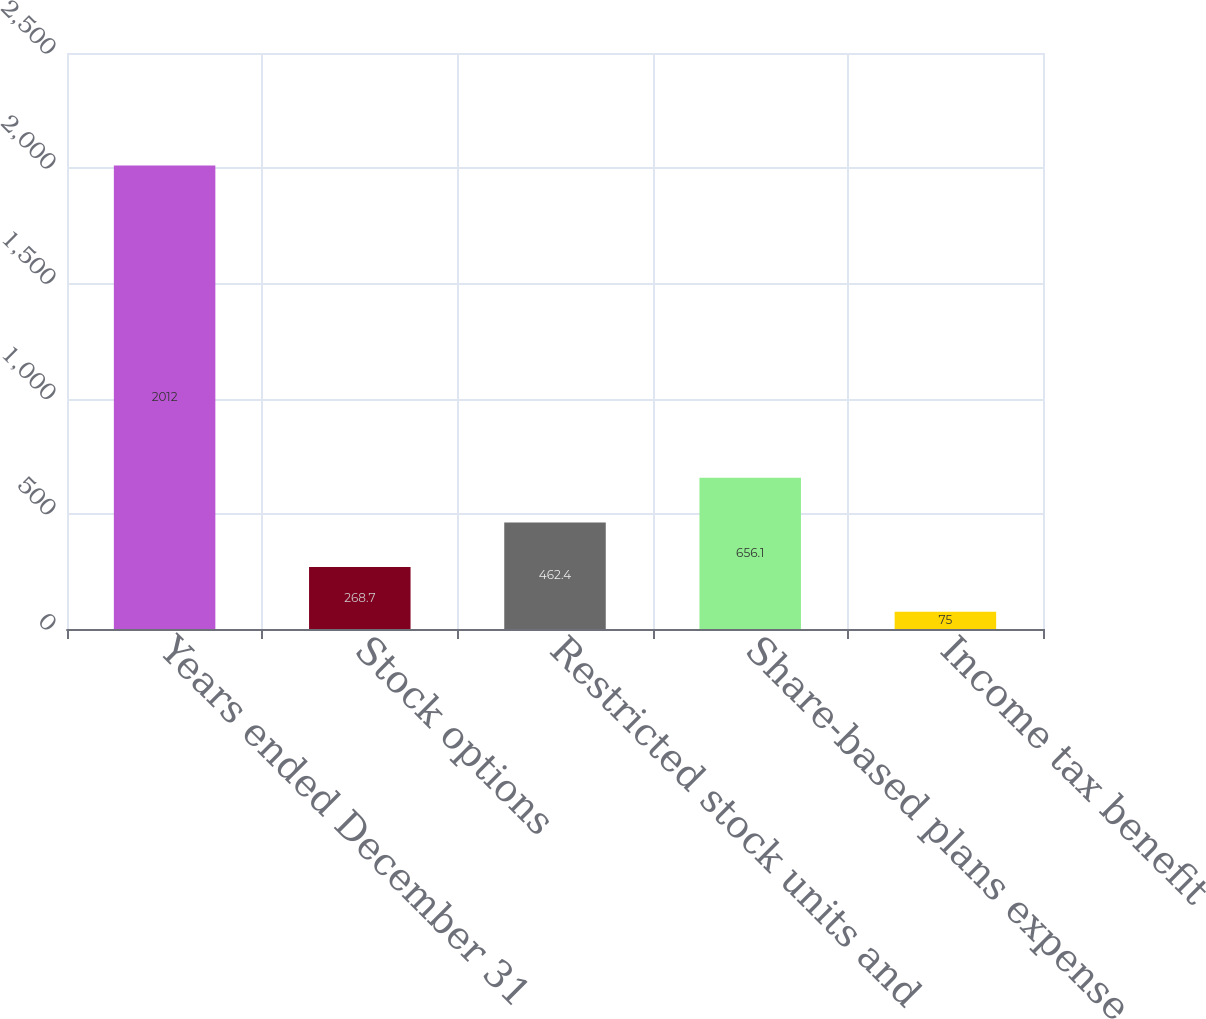<chart> <loc_0><loc_0><loc_500><loc_500><bar_chart><fcel>Years ended December 31<fcel>Stock options<fcel>Restricted stock units and<fcel>Share-based plans expense<fcel>Income tax benefit<nl><fcel>2012<fcel>268.7<fcel>462.4<fcel>656.1<fcel>75<nl></chart> 